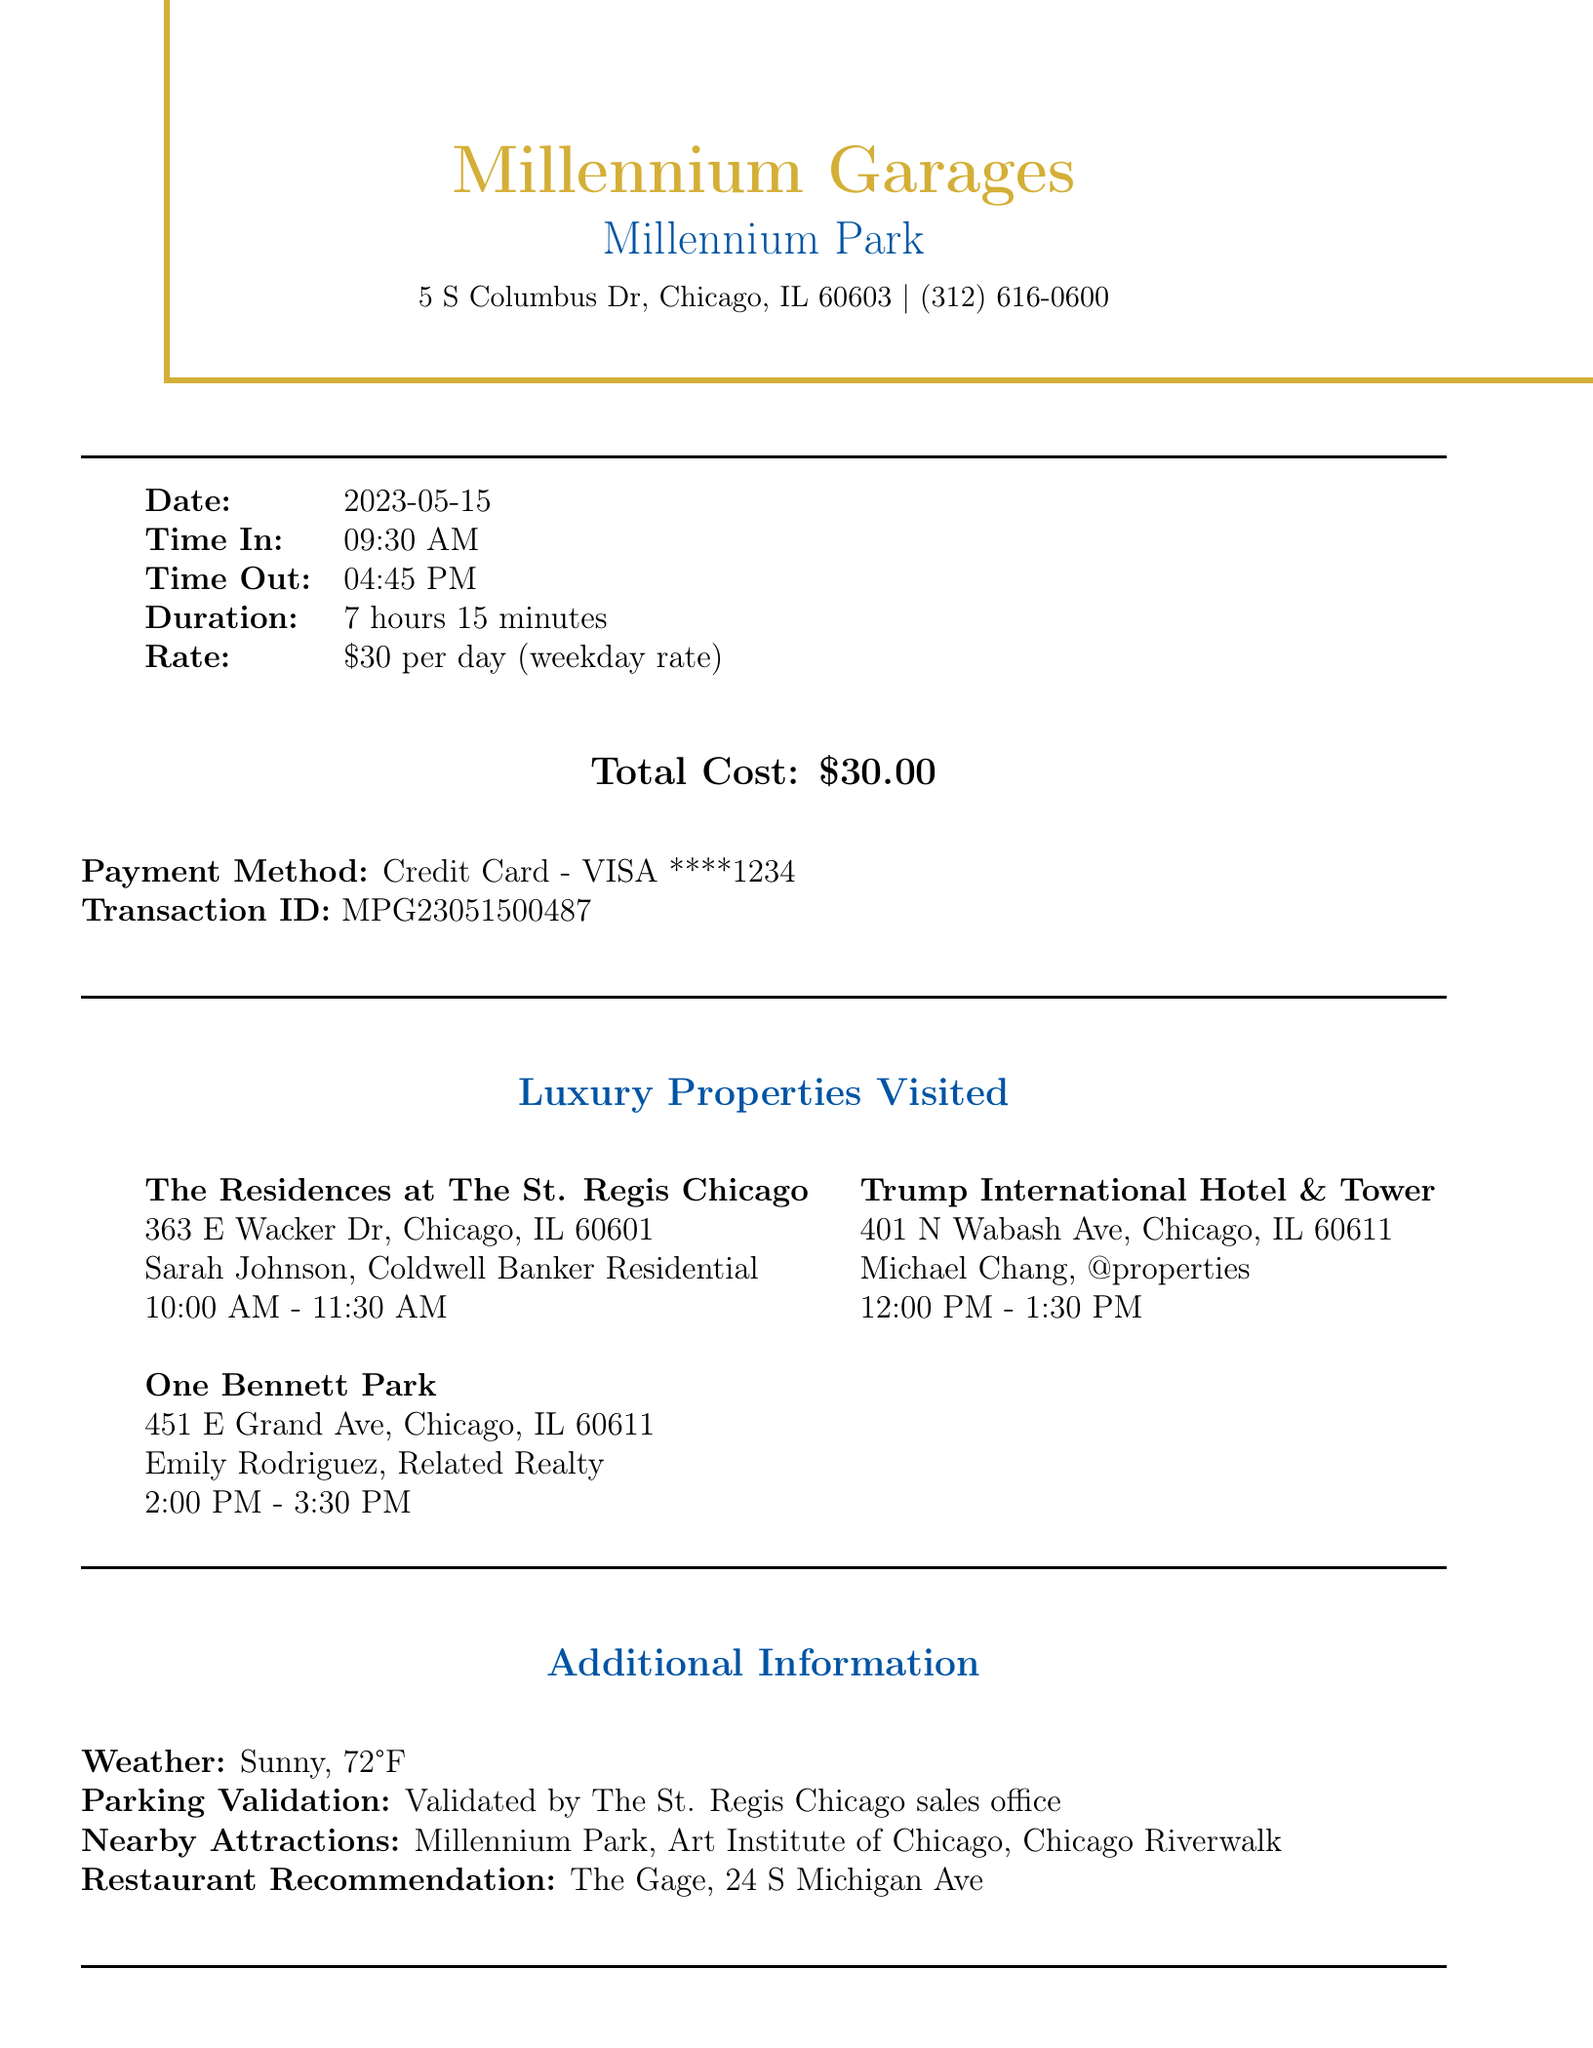What is the parking garage name? The name of the parking garage is listed at the top of the document.
Answer: Millennium Garages - Millennium Park What is the address of the parking garage? The address of the parking garage is provided below its name.
Answer: 5 S Columbus Dr, Chicago, IL 60603 What was the time out of the parking garage? The time out is indicated in the parking details section.
Answer: 04:45 PM How long was the parking duration? The duration of parking is detailed in the receipt.
Answer: 7 hours 15 minutes What was the total cost of parking? The total cost appears prominently in the financial summary of the receipt.
Answer: $30.00 Which luxury property was visited first? The first property visited is listed in the luxury properties section.
Answer: The Residences at The St. Regis Chicago Who was the realtor for the second property? The realtor's name is specified next to the second luxury property visited.
Answer: Michael Chang, @properties What is the weather on the day of the visit? The weather condition is noted in the additional information section of the document.
Answer: Sunny, 72°F What restaurant is recommended? The recommended restaurant is mentioned in the additional information section.
Answer: The Gage, 24 S Michigan Ave 